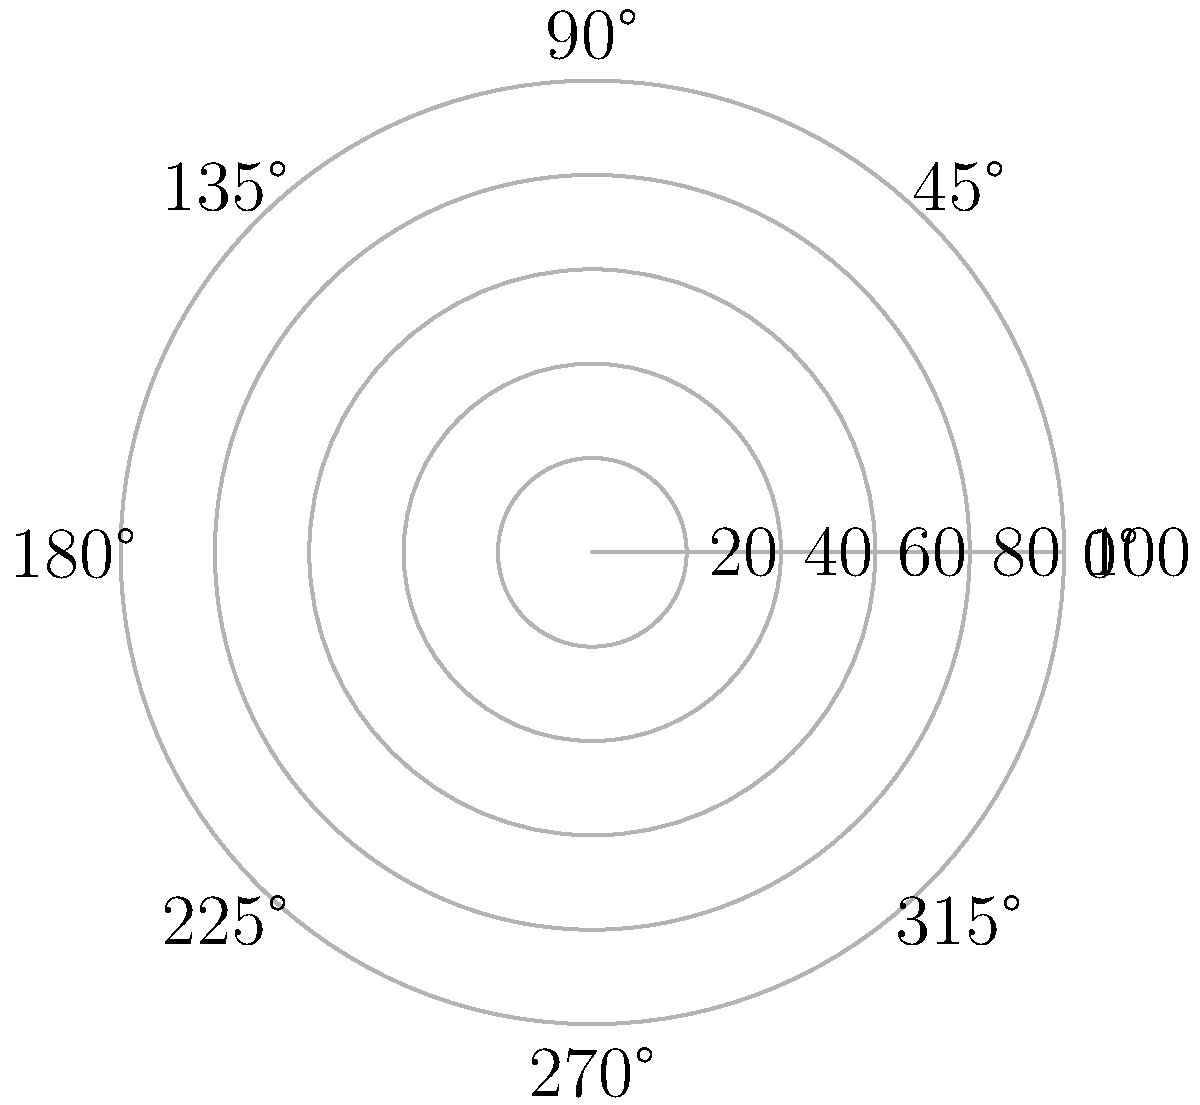The polar plot shows the spread of antibiotic resistance in a bacterial population over time. Each concentric circle represents a 20% increase in resistance, while the angles represent time in hours. If the bacteria reach 100% resistance after 14 hours, what is the average rate of increase in antibiotic resistance per hour? To solve this problem, we need to follow these steps:

1. Identify the final resistance level and time:
   - Final resistance: 100%
   - Time taken: 14 hours

2. Calculate the total increase in resistance:
   - Initial resistance: 0%
   - Total increase: $100\% - 0\% = 100\%$

3. Calculate the average rate of increase per hour:
   - Average rate = Total increase / Time taken
   - Average rate = $100\% / 14$ hours

4. Simplify the fraction:
   - Average rate = $\frac{100}{14}\% / \text{hour}$
   - Average rate ≈ $7.14\% / \text{hour}$

Therefore, the average rate of increase in antibiotic resistance is approximately $7.14\%$ per hour.
Answer: $7.14\% / \text{hour}$ 